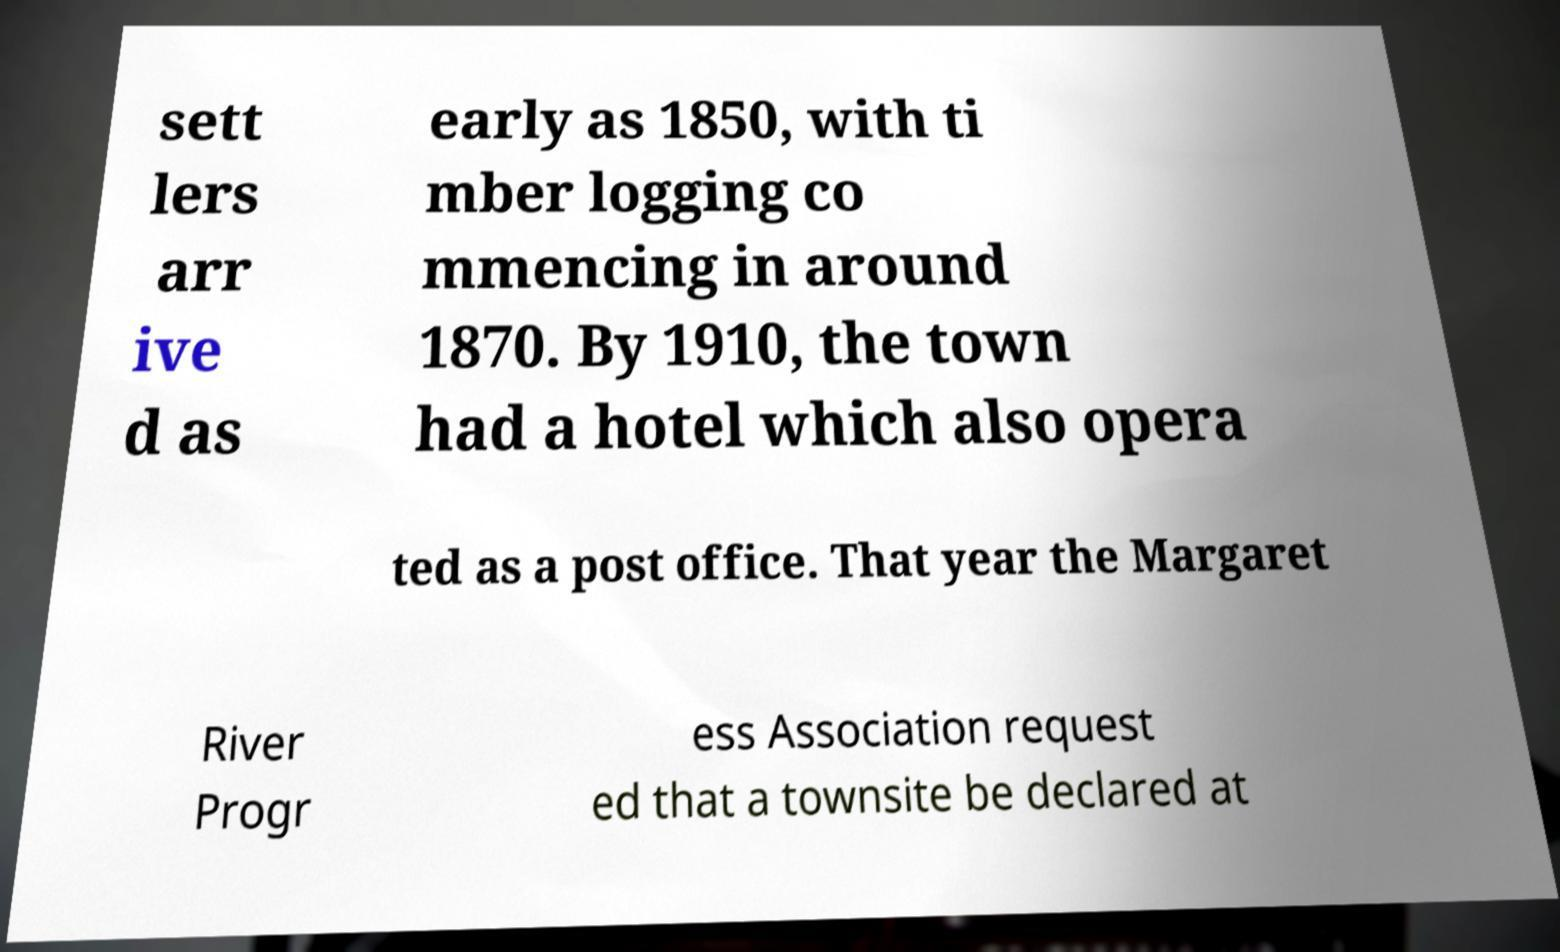For documentation purposes, I need the text within this image transcribed. Could you provide that? sett lers arr ive d as early as 1850, with ti mber logging co mmencing in around 1870. By 1910, the town had a hotel which also opera ted as a post office. That year the Margaret River Progr ess Association request ed that a townsite be declared at 